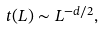Convert formula to latex. <formula><loc_0><loc_0><loc_500><loc_500>t ( L ) \sim L ^ { - d / 2 } ,</formula> 